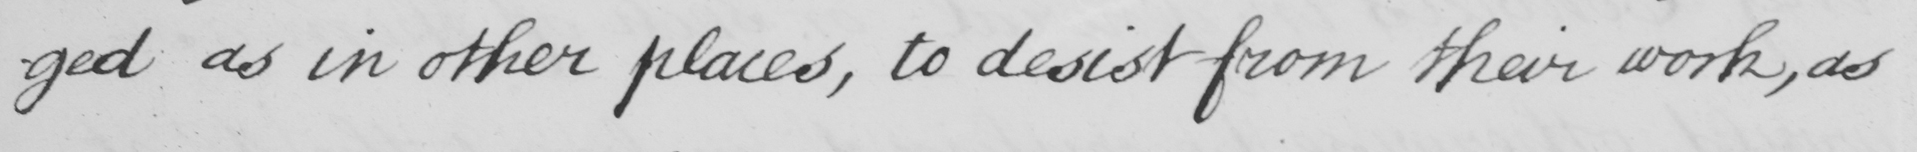What text is written in this handwritten line? -ged as in other places, to desist from their work, as 